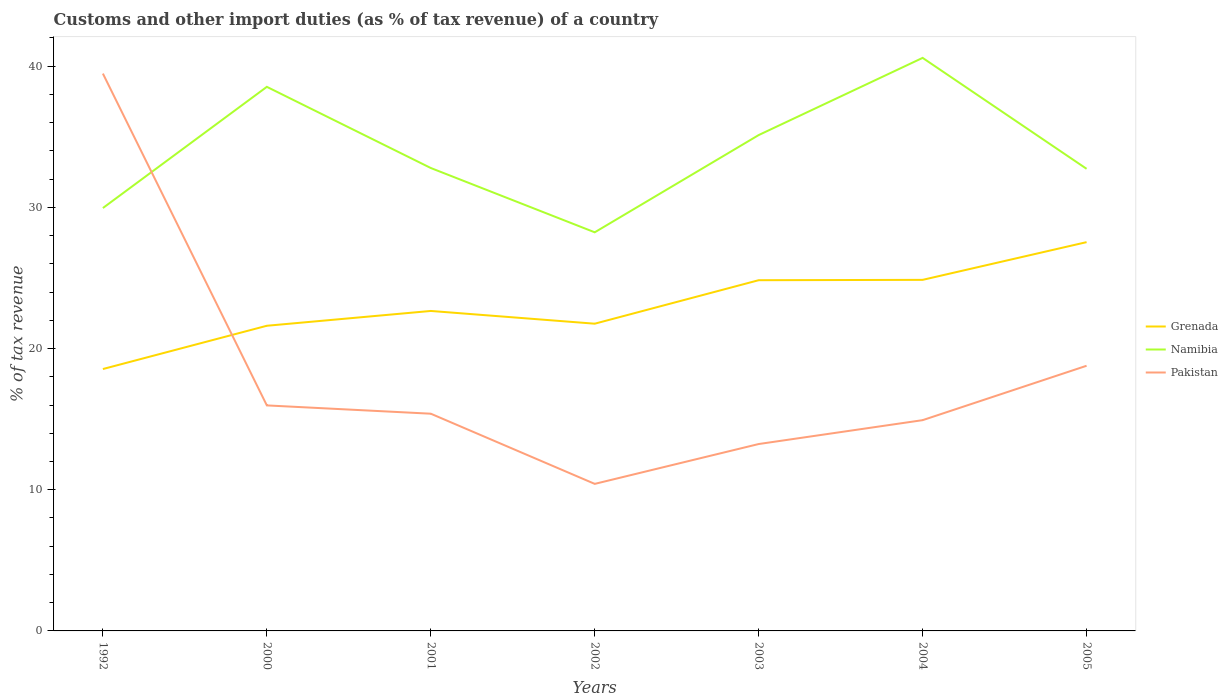Across all years, what is the maximum percentage of tax revenue from customs in Pakistan?
Provide a short and direct response. 10.41. In which year was the percentage of tax revenue from customs in Pakistan maximum?
Your answer should be very brief. 2002. What is the total percentage of tax revenue from customs in Grenada in the graph?
Provide a succinct answer. -6.29. What is the difference between the highest and the second highest percentage of tax revenue from customs in Namibia?
Provide a succinct answer. 12.35. Is the percentage of tax revenue from customs in Namibia strictly greater than the percentage of tax revenue from customs in Grenada over the years?
Make the answer very short. No. Does the graph contain grids?
Give a very brief answer. No. Where does the legend appear in the graph?
Offer a very short reply. Center right. How are the legend labels stacked?
Offer a terse response. Vertical. What is the title of the graph?
Keep it short and to the point. Customs and other import duties (as % of tax revenue) of a country. Does "Euro area" appear as one of the legend labels in the graph?
Ensure brevity in your answer.  No. What is the label or title of the X-axis?
Provide a succinct answer. Years. What is the label or title of the Y-axis?
Provide a succinct answer. % of tax revenue. What is the % of tax revenue of Grenada in 1992?
Your answer should be very brief. 18.55. What is the % of tax revenue of Namibia in 1992?
Offer a terse response. 29.95. What is the % of tax revenue of Pakistan in 1992?
Provide a succinct answer. 39.48. What is the % of tax revenue in Grenada in 2000?
Provide a succinct answer. 21.61. What is the % of tax revenue in Namibia in 2000?
Provide a short and direct response. 38.54. What is the % of tax revenue in Pakistan in 2000?
Offer a terse response. 15.97. What is the % of tax revenue of Grenada in 2001?
Your response must be concise. 22.66. What is the % of tax revenue of Namibia in 2001?
Provide a short and direct response. 32.79. What is the % of tax revenue in Pakistan in 2001?
Make the answer very short. 15.39. What is the % of tax revenue of Grenada in 2002?
Your answer should be very brief. 21.76. What is the % of tax revenue of Namibia in 2002?
Your answer should be very brief. 28.23. What is the % of tax revenue of Pakistan in 2002?
Your answer should be compact. 10.41. What is the % of tax revenue of Grenada in 2003?
Keep it short and to the point. 24.84. What is the % of tax revenue of Namibia in 2003?
Your answer should be very brief. 35.12. What is the % of tax revenue in Pakistan in 2003?
Your answer should be very brief. 13.24. What is the % of tax revenue of Grenada in 2004?
Offer a very short reply. 24.87. What is the % of tax revenue of Namibia in 2004?
Your answer should be compact. 40.59. What is the % of tax revenue of Pakistan in 2004?
Offer a very short reply. 14.93. What is the % of tax revenue in Grenada in 2005?
Offer a terse response. 27.54. What is the % of tax revenue in Namibia in 2005?
Provide a succinct answer. 32.73. What is the % of tax revenue in Pakistan in 2005?
Give a very brief answer. 18.78. Across all years, what is the maximum % of tax revenue in Grenada?
Ensure brevity in your answer.  27.54. Across all years, what is the maximum % of tax revenue of Namibia?
Your answer should be very brief. 40.59. Across all years, what is the maximum % of tax revenue in Pakistan?
Offer a terse response. 39.48. Across all years, what is the minimum % of tax revenue of Grenada?
Provide a succinct answer. 18.55. Across all years, what is the minimum % of tax revenue in Namibia?
Provide a short and direct response. 28.23. Across all years, what is the minimum % of tax revenue of Pakistan?
Offer a terse response. 10.41. What is the total % of tax revenue of Grenada in the graph?
Your answer should be very brief. 161.83. What is the total % of tax revenue of Namibia in the graph?
Your answer should be very brief. 237.95. What is the total % of tax revenue in Pakistan in the graph?
Offer a very short reply. 128.2. What is the difference between the % of tax revenue of Grenada in 1992 and that in 2000?
Your answer should be compact. -3.06. What is the difference between the % of tax revenue of Namibia in 1992 and that in 2000?
Provide a short and direct response. -8.58. What is the difference between the % of tax revenue in Pakistan in 1992 and that in 2000?
Ensure brevity in your answer.  23.5. What is the difference between the % of tax revenue in Grenada in 1992 and that in 2001?
Offer a terse response. -4.11. What is the difference between the % of tax revenue of Namibia in 1992 and that in 2001?
Your response must be concise. -2.84. What is the difference between the % of tax revenue in Pakistan in 1992 and that in 2001?
Ensure brevity in your answer.  24.09. What is the difference between the % of tax revenue of Grenada in 1992 and that in 2002?
Your response must be concise. -3.21. What is the difference between the % of tax revenue of Namibia in 1992 and that in 2002?
Your answer should be compact. 1.72. What is the difference between the % of tax revenue in Pakistan in 1992 and that in 2002?
Your response must be concise. 29.06. What is the difference between the % of tax revenue in Grenada in 1992 and that in 2003?
Offer a very short reply. -6.29. What is the difference between the % of tax revenue of Namibia in 1992 and that in 2003?
Keep it short and to the point. -5.17. What is the difference between the % of tax revenue of Pakistan in 1992 and that in 2003?
Make the answer very short. 26.24. What is the difference between the % of tax revenue in Grenada in 1992 and that in 2004?
Keep it short and to the point. -6.32. What is the difference between the % of tax revenue of Namibia in 1992 and that in 2004?
Provide a short and direct response. -10.64. What is the difference between the % of tax revenue of Pakistan in 1992 and that in 2004?
Provide a succinct answer. 24.55. What is the difference between the % of tax revenue in Grenada in 1992 and that in 2005?
Your answer should be compact. -8.99. What is the difference between the % of tax revenue of Namibia in 1992 and that in 2005?
Your answer should be very brief. -2.78. What is the difference between the % of tax revenue of Pakistan in 1992 and that in 2005?
Offer a terse response. 20.7. What is the difference between the % of tax revenue of Grenada in 2000 and that in 2001?
Your answer should be very brief. -1.05. What is the difference between the % of tax revenue in Namibia in 2000 and that in 2001?
Provide a succinct answer. 5.75. What is the difference between the % of tax revenue of Pakistan in 2000 and that in 2001?
Offer a terse response. 0.59. What is the difference between the % of tax revenue in Grenada in 2000 and that in 2002?
Offer a very short reply. -0.15. What is the difference between the % of tax revenue in Namibia in 2000 and that in 2002?
Ensure brevity in your answer.  10.3. What is the difference between the % of tax revenue in Pakistan in 2000 and that in 2002?
Provide a short and direct response. 5.56. What is the difference between the % of tax revenue in Grenada in 2000 and that in 2003?
Ensure brevity in your answer.  -3.23. What is the difference between the % of tax revenue in Namibia in 2000 and that in 2003?
Your response must be concise. 3.42. What is the difference between the % of tax revenue of Pakistan in 2000 and that in 2003?
Provide a short and direct response. 2.74. What is the difference between the % of tax revenue of Grenada in 2000 and that in 2004?
Offer a very short reply. -3.25. What is the difference between the % of tax revenue in Namibia in 2000 and that in 2004?
Offer a very short reply. -2.05. What is the difference between the % of tax revenue in Pakistan in 2000 and that in 2004?
Provide a succinct answer. 1.04. What is the difference between the % of tax revenue in Grenada in 2000 and that in 2005?
Offer a terse response. -5.92. What is the difference between the % of tax revenue of Namibia in 2000 and that in 2005?
Ensure brevity in your answer.  5.81. What is the difference between the % of tax revenue in Pakistan in 2000 and that in 2005?
Ensure brevity in your answer.  -2.81. What is the difference between the % of tax revenue of Grenada in 2001 and that in 2002?
Your response must be concise. 0.9. What is the difference between the % of tax revenue of Namibia in 2001 and that in 2002?
Make the answer very short. 4.55. What is the difference between the % of tax revenue of Pakistan in 2001 and that in 2002?
Make the answer very short. 4.97. What is the difference between the % of tax revenue of Grenada in 2001 and that in 2003?
Keep it short and to the point. -2.18. What is the difference between the % of tax revenue of Namibia in 2001 and that in 2003?
Offer a very short reply. -2.33. What is the difference between the % of tax revenue in Pakistan in 2001 and that in 2003?
Your answer should be very brief. 2.15. What is the difference between the % of tax revenue in Grenada in 2001 and that in 2004?
Offer a terse response. -2.2. What is the difference between the % of tax revenue in Namibia in 2001 and that in 2004?
Provide a short and direct response. -7.8. What is the difference between the % of tax revenue of Pakistan in 2001 and that in 2004?
Provide a succinct answer. 0.46. What is the difference between the % of tax revenue of Grenada in 2001 and that in 2005?
Offer a very short reply. -4.87. What is the difference between the % of tax revenue of Namibia in 2001 and that in 2005?
Offer a terse response. 0.06. What is the difference between the % of tax revenue in Pakistan in 2001 and that in 2005?
Your answer should be compact. -3.4. What is the difference between the % of tax revenue of Grenada in 2002 and that in 2003?
Ensure brevity in your answer.  -3.08. What is the difference between the % of tax revenue in Namibia in 2002 and that in 2003?
Offer a terse response. -6.89. What is the difference between the % of tax revenue of Pakistan in 2002 and that in 2003?
Provide a short and direct response. -2.82. What is the difference between the % of tax revenue in Grenada in 2002 and that in 2004?
Offer a terse response. -3.11. What is the difference between the % of tax revenue in Namibia in 2002 and that in 2004?
Provide a short and direct response. -12.35. What is the difference between the % of tax revenue in Pakistan in 2002 and that in 2004?
Make the answer very short. -4.51. What is the difference between the % of tax revenue in Grenada in 2002 and that in 2005?
Give a very brief answer. -5.78. What is the difference between the % of tax revenue of Namibia in 2002 and that in 2005?
Give a very brief answer. -4.5. What is the difference between the % of tax revenue of Pakistan in 2002 and that in 2005?
Your answer should be very brief. -8.37. What is the difference between the % of tax revenue of Grenada in 2003 and that in 2004?
Ensure brevity in your answer.  -0.03. What is the difference between the % of tax revenue in Namibia in 2003 and that in 2004?
Your answer should be very brief. -5.47. What is the difference between the % of tax revenue of Pakistan in 2003 and that in 2004?
Give a very brief answer. -1.69. What is the difference between the % of tax revenue of Grenada in 2003 and that in 2005?
Ensure brevity in your answer.  -2.7. What is the difference between the % of tax revenue in Namibia in 2003 and that in 2005?
Provide a short and direct response. 2.39. What is the difference between the % of tax revenue of Pakistan in 2003 and that in 2005?
Make the answer very short. -5.54. What is the difference between the % of tax revenue in Grenada in 2004 and that in 2005?
Your answer should be compact. -2.67. What is the difference between the % of tax revenue of Namibia in 2004 and that in 2005?
Your answer should be very brief. 7.86. What is the difference between the % of tax revenue of Pakistan in 2004 and that in 2005?
Make the answer very short. -3.85. What is the difference between the % of tax revenue of Grenada in 1992 and the % of tax revenue of Namibia in 2000?
Offer a terse response. -19.99. What is the difference between the % of tax revenue in Grenada in 1992 and the % of tax revenue in Pakistan in 2000?
Provide a succinct answer. 2.58. What is the difference between the % of tax revenue of Namibia in 1992 and the % of tax revenue of Pakistan in 2000?
Your answer should be very brief. 13.98. What is the difference between the % of tax revenue in Grenada in 1992 and the % of tax revenue in Namibia in 2001?
Provide a succinct answer. -14.24. What is the difference between the % of tax revenue in Grenada in 1992 and the % of tax revenue in Pakistan in 2001?
Provide a succinct answer. 3.16. What is the difference between the % of tax revenue in Namibia in 1992 and the % of tax revenue in Pakistan in 2001?
Give a very brief answer. 14.57. What is the difference between the % of tax revenue in Grenada in 1992 and the % of tax revenue in Namibia in 2002?
Make the answer very short. -9.68. What is the difference between the % of tax revenue in Grenada in 1992 and the % of tax revenue in Pakistan in 2002?
Provide a short and direct response. 8.13. What is the difference between the % of tax revenue of Namibia in 1992 and the % of tax revenue of Pakistan in 2002?
Ensure brevity in your answer.  19.54. What is the difference between the % of tax revenue in Grenada in 1992 and the % of tax revenue in Namibia in 2003?
Ensure brevity in your answer.  -16.57. What is the difference between the % of tax revenue of Grenada in 1992 and the % of tax revenue of Pakistan in 2003?
Give a very brief answer. 5.31. What is the difference between the % of tax revenue in Namibia in 1992 and the % of tax revenue in Pakistan in 2003?
Give a very brief answer. 16.71. What is the difference between the % of tax revenue in Grenada in 1992 and the % of tax revenue in Namibia in 2004?
Offer a very short reply. -22.04. What is the difference between the % of tax revenue in Grenada in 1992 and the % of tax revenue in Pakistan in 2004?
Make the answer very short. 3.62. What is the difference between the % of tax revenue of Namibia in 1992 and the % of tax revenue of Pakistan in 2004?
Provide a short and direct response. 15.02. What is the difference between the % of tax revenue of Grenada in 1992 and the % of tax revenue of Namibia in 2005?
Provide a short and direct response. -14.18. What is the difference between the % of tax revenue in Grenada in 1992 and the % of tax revenue in Pakistan in 2005?
Your answer should be compact. -0.23. What is the difference between the % of tax revenue of Namibia in 1992 and the % of tax revenue of Pakistan in 2005?
Keep it short and to the point. 11.17. What is the difference between the % of tax revenue in Grenada in 2000 and the % of tax revenue in Namibia in 2001?
Offer a terse response. -11.17. What is the difference between the % of tax revenue of Grenada in 2000 and the % of tax revenue of Pakistan in 2001?
Keep it short and to the point. 6.23. What is the difference between the % of tax revenue in Namibia in 2000 and the % of tax revenue in Pakistan in 2001?
Make the answer very short. 23.15. What is the difference between the % of tax revenue in Grenada in 2000 and the % of tax revenue in Namibia in 2002?
Your answer should be very brief. -6.62. What is the difference between the % of tax revenue in Grenada in 2000 and the % of tax revenue in Pakistan in 2002?
Offer a terse response. 11.2. What is the difference between the % of tax revenue in Namibia in 2000 and the % of tax revenue in Pakistan in 2002?
Make the answer very short. 28.12. What is the difference between the % of tax revenue in Grenada in 2000 and the % of tax revenue in Namibia in 2003?
Keep it short and to the point. -13.51. What is the difference between the % of tax revenue in Grenada in 2000 and the % of tax revenue in Pakistan in 2003?
Make the answer very short. 8.38. What is the difference between the % of tax revenue in Namibia in 2000 and the % of tax revenue in Pakistan in 2003?
Provide a succinct answer. 25.3. What is the difference between the % of tax revenue of Grenada in 2000 and the % of tax revenue of Namibia in 2004?
Make the answer very short. -18.97. What is the difference between the % of tax revenue of Grenada in 2000 and the % of tax revenue of Pakistan in 2004?
Offer a very short reply. 6.69. What is the difference between the % of tax revenue of Namibia in 2000 and the % of tax revenue of Pakistan in 2004?
Make the answer very short. 23.61. What is the difference between the % of tax revenue in Grenada in 2000 and the % of tax revenue in Namibia in 2005?
Offer a terse response. -11.12. What is the difference between the % of tax revenue of Grenada in 2000 and the % of tax revenue of Pakistan in 2005?
Give a very brief answer. 2.83. What is the difference between the % of tax revenue of Namibia in 2000 and the % of tax revenue of Pakistan in 2005?
Give a very brief answer. 19.76. What is the difference between the % of tax revenue in Grenada in 2001 and the % of tax revenue in Namibia in 2002?
Provide a succinct answer. -5.57. What is the difference between the % of tax revenue in Grenada in 2001 and the % of tax revenue in Pakistan in 2002?
Provide a short and direct response. 12.25. What is the difference between the % of tax revenue in Namibia in 2001 and the % of tax revenue in Pakistan in 2002?
Provide a short and direct response. 22.37. What is the difference between the % of tax revenue of Grenada in 2001 and the % of tax revenue of Namibia in 2003?
Make the answer very short. -12.46. What is the difference between the % of tax revenue of Grenada in 2001 and the % of tax revenue of Pakistan in 2003?
Ensure brevity in your answer.  9.43. What is the difference between the % of tax revenue in Namibia in 2001 and the % of tax revenue in Pakistan in 2003?
Your answer should be compact. 19.55. What is the difference between the % of tax revenue of Grenada in 2001 and the % of tax revenue of Namibia in 2004?
Provide a short and direct response. -17.93. What is the difference between the % of tax revenue of Grenada in 2001 and the % of tax revenue of Pakistan in 2004?
Give a very brief answer. 7.73. What is the difference between the % of tax revenue of Namibia in 2001 and the % of tax revenue of Pakistan in 2004?
Provide a succinct answer. 17.86. What is the difference between the % of tax revenue of Grenada in 2001 and the % of tax revenue of Namibia in 2005?
Provide a short and direct response. -10.07. What is the difference between the % of tax revenue in Grenada in 2001 and the % of tax revenue in Pakistan in 2005?
Provide a short and direct response. 3.88. What is the difference between the % of tax revenue of Namibia in 2001 and the % of tax revenue of Pakistan in 2005?
Provide a succinct answer. 14.01. What is the difference between the % of tax revenue of Grenada in 2002 and the % of tax revenue of Namibia in 2003?
Your response must be concise. -13.36. What is the difference between the % of tax revenue of Grenada in 2002 and the % of tax revenue of Pakistan in 2003?
Provide a succinct answer. 8.52. What is the difference between the % of tax revenue of Namibia in 2002 and the % of tax revenue of Pakistan in 2003?
Your answer should be very brief. 15. What is the difference between the % of tax revenue in Grenada in 2002 and the % of tax revenue in Namibia in 2004?
Your answer should be compact. -18.83. What is the difference between the % of tax revenue in Grenada in 2002 and the % of tax revenue in Pakistan in 2004?
Your answer should be compact. 6.83. What is the difference between the % of tax revenue in Namibia in 2002 and the % of tax revenue in Pakistan in 2004?
Provide a short and direct response. 13.31. What is the difference between the % of tax revenue of Grenada in 2002 and the % of tax revenue of Namibia in 2005?
Offer a terse response. -10.97. What is the difference between the % of tax revenue in Grenada in 2002 and the % of tax revenue in Pakistan in 2005?
Provide a succinct answer. 2.98. What is the difference between the % of tax revenue in Namibia in 2002 and the % of tax revenue in Pakistan in 2005?
Provide a succinct answer. 9.45. What is the difference between the % of tax revenue of Grenada in 2003 and the % of tax revenue of Namibia in 2004?
Provide a short and direct response. -15.75. What is the difference between the % of tax revenue in Grenada in 2003 and the % of tax revenue in Pakistan in 2004?
Make the answer very short. 9.91. What is the difference between the % of tax revenue in Namibia in 2003 and the % of tax revenue in Pakistan in 2004?
Your answer should be very brief. 20.19. What is the difference between the % of tax revenue of Grenada in 2003 and the % of tax revenue of Namibia in 2005?
Offer a very short reply. -7.89. What is the difference between the % of tax revenue in Grenada in 2003 and the % of tax revenue in Pakistan in 2005?
Keep it short and to the point. 6.06. What is the difference between the % of tax revenue in Namibia in 2003 and the % of tax revenue in Pakistan in 2005?
Your answer should be very brief. 16.34. What is the difference between the % of tax revenue in Grenada in 2004 and the % of tax revenue in Namibia in 2005?
Offer a very short reply. -7.86. What is the difference between the % of tax revenue in Grenada in 2004 and the % of tax revenue in Pakistan in 2005?
Offer a terse response. 6.08. What is the difference between the % of tax revenue of Namibia in 2004 and the % of tax revenue of Pakistan in 2005?
Your response must be concise. 21.81. What is the average % of tax revenue in Grenada per year?
Make the answer very short. 23.12. What is the average % of tax revenue in Namibia per year?
Make the answer very short. 33.99. What is the average % of tax revenue in Pakistan per year?
Make the answer very short. 18.31. In the year 1992, what is the difference between the % of tax revenue in Grenada and % of tax revenue in Namibia?
Offer a very short reply. -11.4. In the year 1992, what is the difference between the % of tax revenue of Grenada and % of tax revenue of Pakistan?
Offer a very short reply. -20.93. In the year 1992, what is the difference between the % of tax revenue in Namibia and % of tax revenue in Pakistan?
Keep it short and to the point. -9.52. In the year 2000, what is the difference between the % of tax revenue of Grenada and % of tax revenue of Namibia?
Offer a terse response. -16.92. In the year 2000, what is the difference between the % of tax revenue in Grenada and % of tax revenue in Pakistan?
Your answer should be very brief. 5.64. In the year 2000, what is the difference between the % of tax revenue in Namibia and % of tax revenue in Pakistan?
Your answer should be compact. 22.56. In the year 2001, what is the difference between the % of tax revenue in Grenada and % of tax revenue in Namibia?
Give a very brief answer. -10.13. In the year 2001, what is the difference between the % of tax revenue in Grenada and % of tax revenue in Pakistan?
Provide a succinct answer. 7.28. In the year 2001, what is the difference between the % of tax revenue of Namibia and % of tax revenue of Pakistan?
Your answer should be very brief. 17.4. In the year 2002, what is the difference between the % of tax revenue of Grenada and % of tax revenue of Namibia?
Your answer should be very brief. -6.47. In the year 2002, what is the difference between the % of tax revenue of Grenada and % of tax revenue of Pakistan?
Make the answer very short. 11.35. In the year 2002, what is the difference between the % of tax revenue in Namibia and % of tax revenue in Pakistan?
Make the answer very short. 17.82. In the year 2003, what is the difference between the % of tax revenue of Grenada and % of tax revenue of Namibia?
Keep it short and to the point. -10.28. In the year 2003, what is the difference between the % of tax revenue in Grenada and % of tax revenue in Pakistan?
Your response must be concise. 11.6. In the year 2003, what is the difference between the % of tax revenue in Namibia and % of tax revenue in Pakistan?
Offer a terse response. 21.88. In the year 2004, what is the difference between the % of tax revenue of Grenada and % of tax revenue of Namibia?
Provide a short and direct response. -15.72. In the year 2004, what is the difference between the % of tax revenue in Grenada and % of tax revenue in Pakistan?
Your answer should be very brief. 9.94. In the year 2004, what is the difference between the % of tax revenue in Namibia and % of tax revenue in Pakistan?
Ensure brevity in your answer.  25.66. In the year 2005, what is the difference between the % of tax revenue in Grenada and % of tax revenue in Namibia?
Your answer should be very brief. -5.19. In the year 2005, what is the difference between the % of tax revenue in Grenada and % of tax revenue in Pakistan?
Provide a short and direct response. 8.76. In the year 2005, what is the difference between the % of tax revenue in Namibia and % of tax revenue in Pakistan?
Offer a very short reply. 13.95. What is the ratio of the % of tax revenue in Grenada in 1992 to that in 2000?
Keep it short and to the point. 0.86. What is the ratio of the % of tax revenue in Namibia in 1992 to that in 2000?
Your answer should be very brief. 0.78. What is the ratio of the % of tax revenue in Pakistan in 1992 to that in 2000?
Offer a terse response. 2.47. What is the ratio of the % of tax revenue of Grenada in 1992 to that in 2001?
Give a very brief answer. 0.82. What is the ratio of the % of tax revenue of Namibia in 1992 to that in 2001?
Your answer should be very brief. 0.91. What is the ratio of the % of tax revenue in Pakistan in 1992 to that in 2001?
Your answer should be compact. 2.57. What is the ratio of the % of tax revenue in Grenada in 1992 to that in 2002?
Provide a succinct answer. 0.85. What is the ratio of the % of tax revenue of Namibia in 1992 to that in 2002?
Ensure brevity in your answer.  1.06. What is the ratio of the % of tax revenue of Pakistan in 1992 to that in 2002?
Provide a succinct answer. 3.79. What is the ratio of the % of tax revenue in Grenada in 1992 to that in 2003?
Offer a very short reply. 0.75. What is the ratio of the % of tax revenue of Namibia in 1992 to that in 2003?
Ensure brevity in your answer.  0.85. What is the ratio of the % of tax revenue of Pakistan in 1992 to that in 2003?
Keep it short and to the point. 2.98. What is the ratio of the % of tax revenue of Grenada in 1992 to that in 2004?
Give a very brief answer. 0.75. What is the ratio of the % of tax revenue in Namibia in 1992 to that in 2004?
Your answer should be very brief. 0.74. What is the ratio of the % of tax revenue in Pakistan in 1992 to that in 2004?
Offer a very short reply. 2.64. What is the ratio of the % of tax revenue in Grenada in 1992 to that in 2005?
Offer a very short reply. 0.67. What is the ratio of the % of tax revenue in Namibia in 1992 to that in 2005?
Ensure brevity in your answer.  0.92. What is the ratio of the % of tax revenue in Pakistan in 1992 to that in 2005?
Make the answer very short. 2.1. What is the ratio of the % of tax revenue in Grenada in 2000 to that in 2001?
Provide a succinct answer. 0.95. What is the ratio of the % of tax revenue of Namibia in 2000 to that in 2001?
Keep it short and to the point. 1.18. What is the ratio of the % of tax revenue of Pakistan in 2000 to that in 2001?
Give a very brief answer. 1.04. What is the ratio of the % of tax revenue of Namibia in 2000 to that in 2002?
Offer a terse response. 1.36. What is the ratio of the % of tax revenue of Pakistan in 2000 to that in 2002?
Your response must be concise. 1.53. What is the ratio of the % of tax revenue in Grenada in 2000 to that in 2003?
Keep it short and to the point. 0.87. What is the ratio of the % of tax revenue in Namibia in 2000 to that in 2003?
Your answer should be very brief. 1.1. What is the ratio of the % of tax revenue of Pakistan in 2000 to that in 2003?
Provide a short and direct response. 1.21. What is the ratio of the % of tax revenue in Grenada in 2000 to that in 2004?
Your answer should be compact. 0.87. What is the ratio of the % of tax revenue in Namibia in 2000 to that in 2004?
Provide a succinct answer. 0.95. What is the ratio of the % of tax revenue in Pakistan in 2000 to that in 2004?
Your response must be concise. 1.07. What is the ratio of the % of tax revenue of Grenada in 2000 to that in 2005?
Keep it short and to the point. 0.78. What is the ratio of the % of tax revenue of Namibia in 2000 to that in 2005?
Give a very brief answer. 1.18. What is the ratio of the % of tax revenue in Pakistan in 2000 to that in 2005?
Provide a succinct answer. 0.85. What is the ratio of the % of tax revenue of Grenada in 2001 to that in 2002?
Make the answer very short. 1.04. What is the ratio of the % of tax revenue of Namibia in 2001 to that in 2002?
Ensure brevity in your answer.  1.16. What is the ratio of the % of tax revenue of Pakistan in 2001 to that in 2002?
Make the answer very short. 1.48. What is the ratio of the % of tax revenue in Grenada in 2001 to that in 2003?
Keep it short and to the point. 0.91. What is the ratio of the % of tax revenue of Namibia in 2001 to that in 2003?
Your answer should be very brief. 0.93. What is the ratio of the % of tax revenue of Pakistan in 2001 to that in 2003?
Offer a very short reply. 1.16. What is the ratio of the % of tax revenue of Grenada in 2001 to that in 2004?
Give a very brief answer. 0.91. What is the ratio of the % of tax revenue of Namibia in 2001 to that in 2004?
Offer a terse response. 0.81. What is the ratio of the % of tax revenue in Pakistan in 2001 to that in 2004?
Give a very brief answer. 1.03. What is the ratio of the % of tax revenue in Grenada in 2001 to that in 2005?
Provide a succinct answer. 0.82. What is the ratio of the % of tax revenue in Namibia in 2001 to that in 2005?
Your answer should be very brief. 1. What is the ratio of the % of tax revenue of Pakistan in 2001 to that in 2005?
Give a very brief answer. 0.82. What is the ratio of the % of tax revenue of Grenada in 2002 to that in 2003?
Offer a terse response. 0.88. What is the ratio of the % of tax revenue in Namibia in 2002 to that in 2003?
Offer a terse response. 0.8. What is the ratio of the % of tax revenue in Pakistan in 2002 to that in 2003?
Your response must be concise. 0.79. What is the ratio of the % of tax revenue of Grenada in 2002 to that in 2004?
Offer a terse response. 0.88. What is the ratio of the % of tax revenue in Namibia in 2002 to that in 2004?
Provide a short and direct response. 0.7. What is the ratio of the % of tax revenue of Pakistan in 2002 to that in 2004?
Offer a very short reply. 0.7. What is the ratio of the % of tax revenue in Grenada in 2002 to that in 2005?
Ensure brevity in your answer.  0.79. What is the ratio of the % of tax revenue of Namibia in 2002 to that in 2005?
Your response must be concise. 0.86. What is the ratio of the % of tax revenue of Pakistan in 2002 to that in 2005?
Your response must be concise. 0.55. What is the ratio of the % of tax revenue of Grenada in 2003 to that in 2004?
Offer a very short reply. 1. What is the ratio of the % of tax revenue of Namibia in 2003 to that in 2004?
Your answer should be very brief. 0.87. What is the ratio of the % of tax revenue of Pakistan in 2003 to that in 2004?
Ensure brevity in your answer.  0.89. What is the ratio of the % of tax revenue of Grenada in 2003 to that in 2005?
Give a very brief answer. 0.9. What is the ratio of the % of tax revenue of Namibia in 2003 to that in 2005?
Make the answer very short. 1.07. What is the ratio of the % of tax revenue in Pakistan in 2003 to that in 2005?
Your answer should be compact. 0.7. What is the ratio of the % of tax revenue in Grenada in 2004 to that in 2005?
Offer a terse response. 0.9. What is the ratio of the % of tax revenue of Namibia in 2004 to that in 2005?
Offer a terse response. 1.24. What is the ratio of the % of tax revenue in Pakistan in 2004 to that in 2005?
Ensure brevity in your answer.  0.79. What is the difference between the highest and the second highest % of tax revenue of Grenada?
Give a very brief answer. 2.67. What is the difference between the highest and the second highest % of tax revenue in Namibia?
Provide a short and direct response. 2.05. What is the difference between the highest and the second highest % of tax revenue in Pakistan?
Your response must be concise. 20.7. What is the difference between the highest and the lowest % of tax revenue of Grenada?
Offer a very short reply. 8.99. What is the difference between the highest and the lowest % of tax revenue of Namibia?
Your answer should be very brief. 12.35. What is the difference between the highest and the lowest % of tax revenue of Pakistan?
Ensure brevity in your answer.  29.06. 